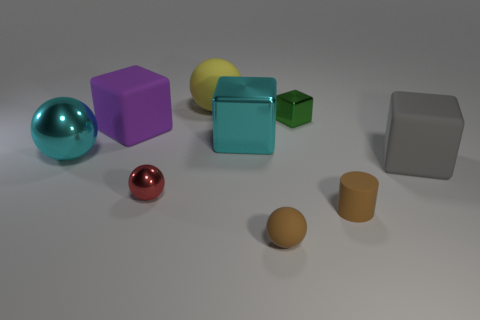Subtract 1 cubes. How many cubes are left? 3 Add 1 large red rubber cubes. How many objects exist? 10 Subtract all cylinders. How many objects are left? 8 Subtract 0 yellow cylinders. How many objects are left? 9 Subtract all small rubber balls. Subtract all large cyan objects. How many objects are left? 6 Add 9 gray rubber things. How many gray rubber things are left? 10 Add 4 big yellow objects. How many big yellow objects exist? 5 